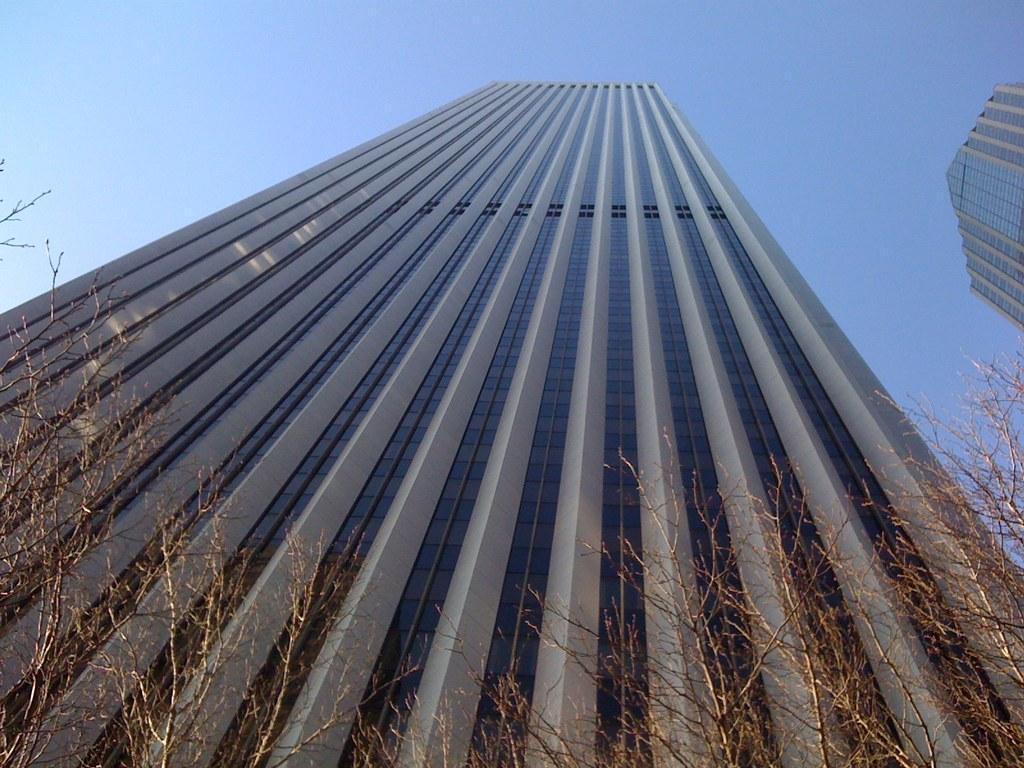What type of structure is visible in the image? There is a building in the image. What is located in front of the building? There is grass in front of the building. What is visible at the top of the image? The sky is visible at the top of the image. How does the orange contribute to the digestion process in the image? There is no orange present in the image, and therefore no contribution to the digestion process can be observed. 